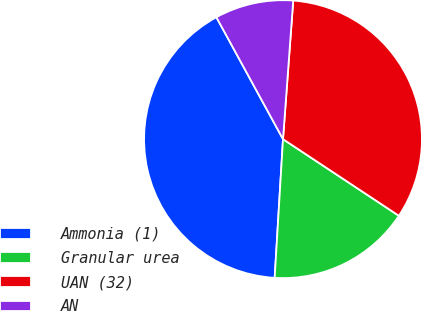Convert chart to OTSL. <chart><loc_0><loc_0><loc_500><loc_500><pie_chart><fcel>Ammonia (1)<fcel>Granular urea<fcel>UAN (32)<fcel>AN<nl><fcel>41.09%<fcel>16.66%<fcel>33.13%<fcel>9.13%<nl></chart> 